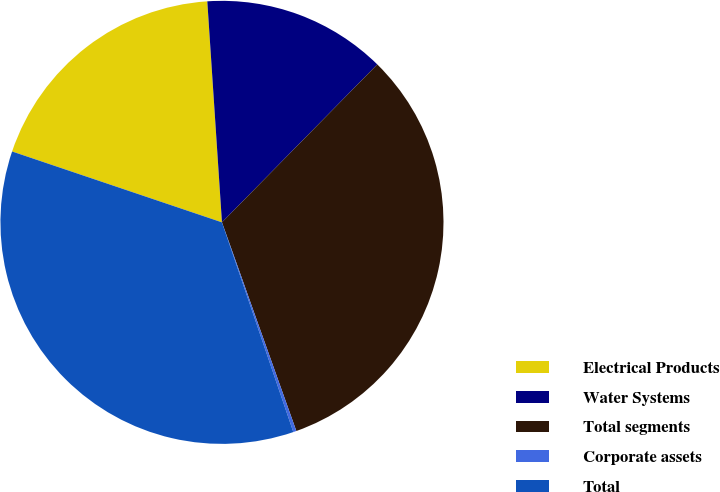Convert chart. <chart><loc_0><loc_0><loc_500><loc_500><pie_chart><fcel>Electrical Products<fcel>Water Systems<fcel>Total segments<fcel>Corporate assets<fcel>Total<nl><fcel>18.76%<fcel>13.42%<fcel>32.18%<fcel>0.23%<fcel>35.4%<nl></chart> 